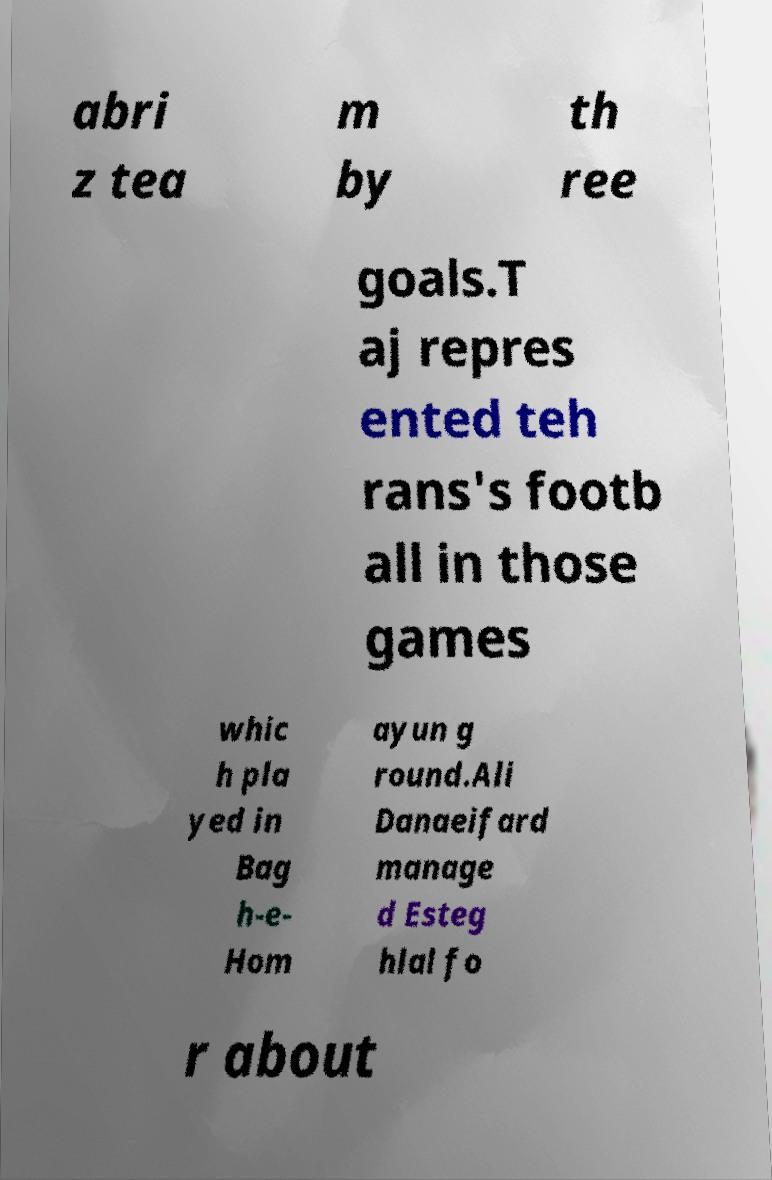Could you assist in decoding the text presented in this image and type it out clearly? abri z tea m by th ree goals.T aj repres ented teh rans's footb all in those games whic h pla yed in Bag h-e- Hom ayun g round.Ali Danaeifard manage d Esteg hlal fo r about 